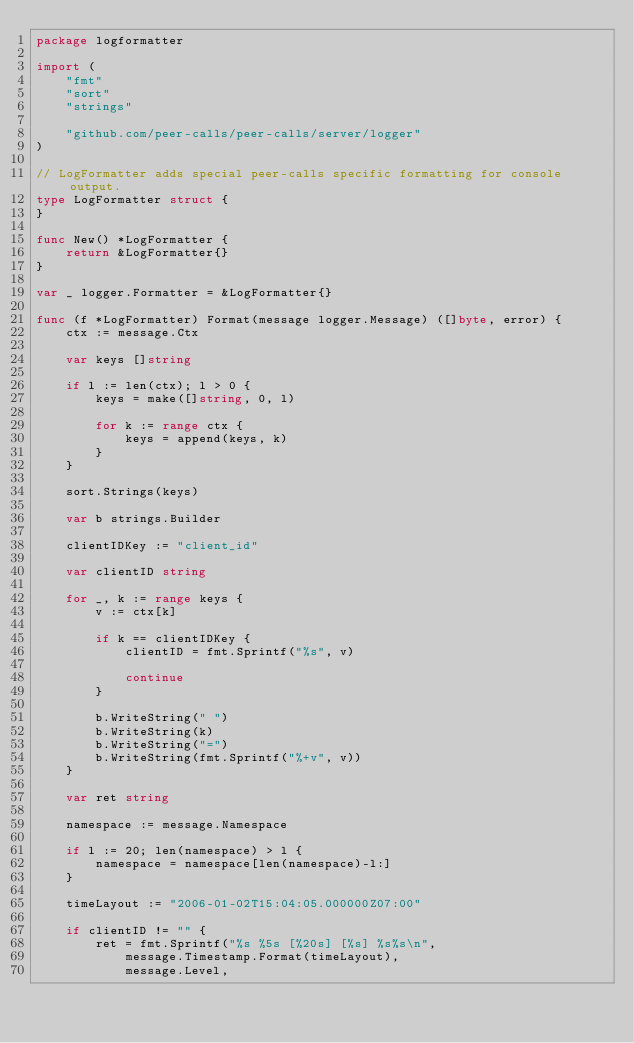Convert code to text. <code><loc_0><loc_0><loc_500><loc_500><_Go_>package logformatter

import (
	"fmt"
	"sort"
	"strings"

	"github.com/peer-calls/peer-calls/server/logger"
)

// LogFormatter adds special peer-calls specific formatting for console output.
type LogFormatter struct {
}

func New() *LogFormatter {
	return &LogFormatter{}
}

var _ logger.Formatter = &LogFormatter{}

func (f *LogFormatter) Format(message logger.Message) ([]byte, error) {
	ctx := message.Ctx

	var keys []string

	if l := len(ctx); l > 0 {
		keys = make([]string, 0, l)

		for k := range ctx {
			keys = append(keys, k)
		}
	}

	sort.Strings(keys)

	var b strings.Builder

	clientIDKey := "client_id"

	var clientID string

	for _, k := range keys {
		v := ctx[k]

		if k == clientIDKey {
			clientID = fmt.Sprintf("%s", v)

			continue
		}

		b.WriteString(" ")
		b.WriteString(k)
		b.WriteString("=")
		b.WriteString(fmt.Sprintf("%+v", v))
	}

	var ret string

	namespace := message.Namespace

	if l := 20; len(namespace) > l {
		namespace = namespace[len(namespace)-l:]
	}

	timeLayout := "2006-01-02T15:04:05.000000Z07:00"

	if clientID != "" {
		ret = fmt.Sprintf("%s %5s [%20s] [%s] %s%s\n",
			message.Timestamp.Format(timeLayout),
			message.Level,</code> 